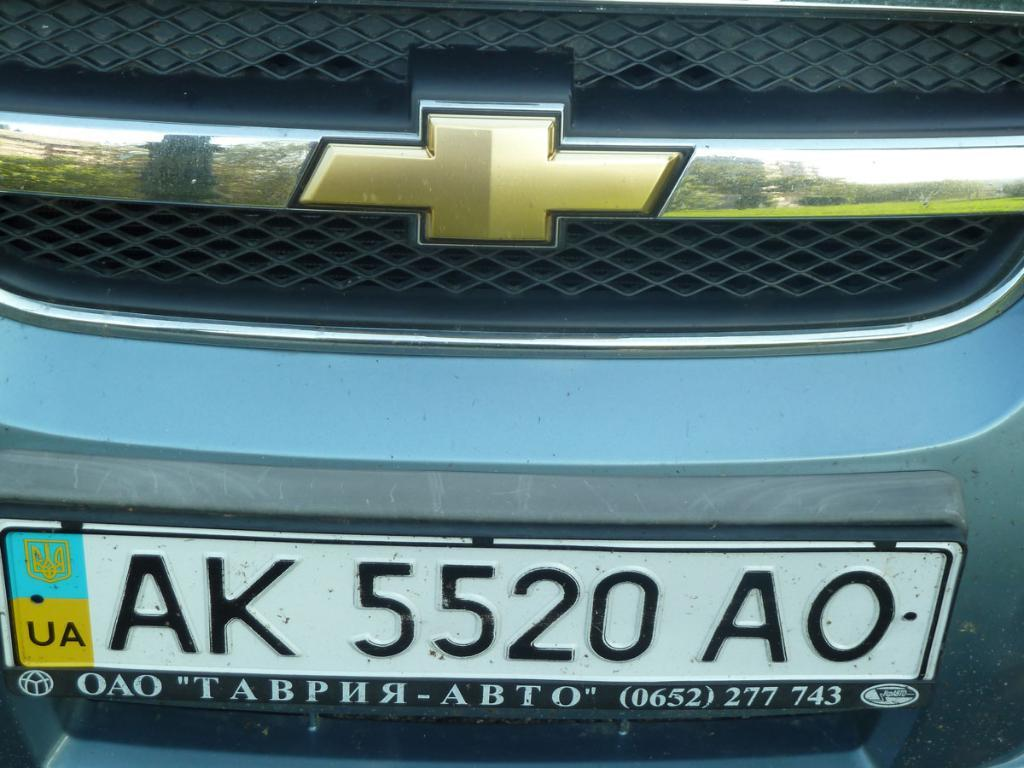<image>
Share a concise interpretation of the image provided. a license plate that has AK written on it 